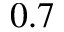Convert formula to latex. <formula><loc_0><loc_0><loc_500><loc_500>0 . 7</formula> 